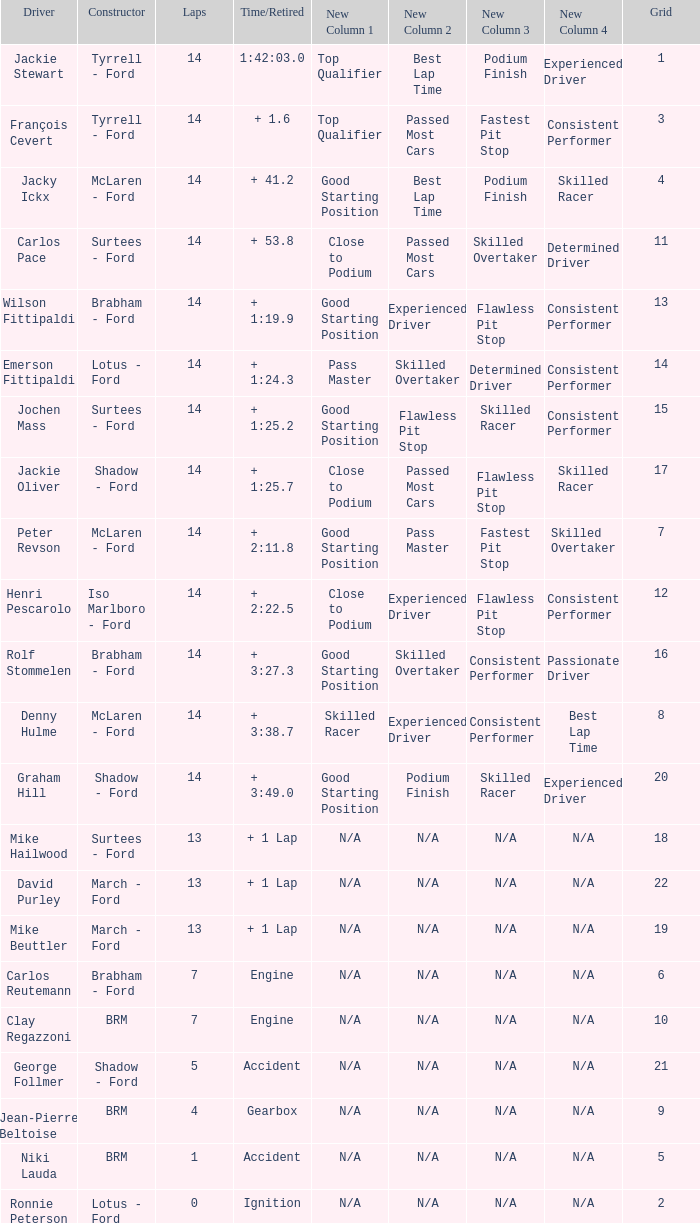What is the low lap total for henri pescarolo with a grad larger than 6? 14.0. 